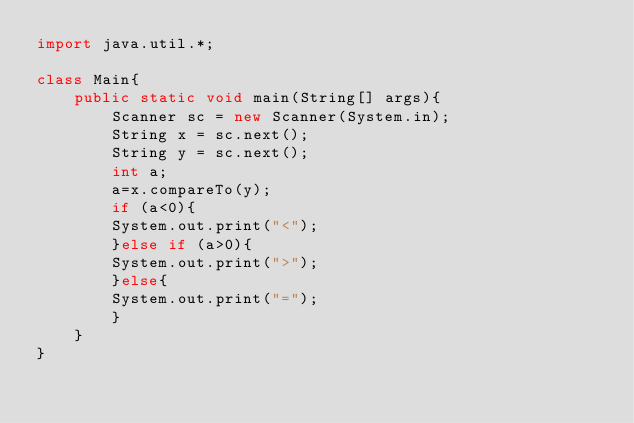Convert code to text. <code><loc_0><loc_0><loc_500><loc_500><_Java_>import java.util.*;

class Main{
    public static void main(String[] args){
        Scanner sc = new Scanner(System.in);
		String x = sc.next();
		String y = sc.next();
		int a;
		a=x.compareTo(y);
		if (a<0){
		System.out.print("<");
        }else if (a>0){
        System.out.print(">");
        }else{
        System.out.print("=");
        }
    }
}</code> 